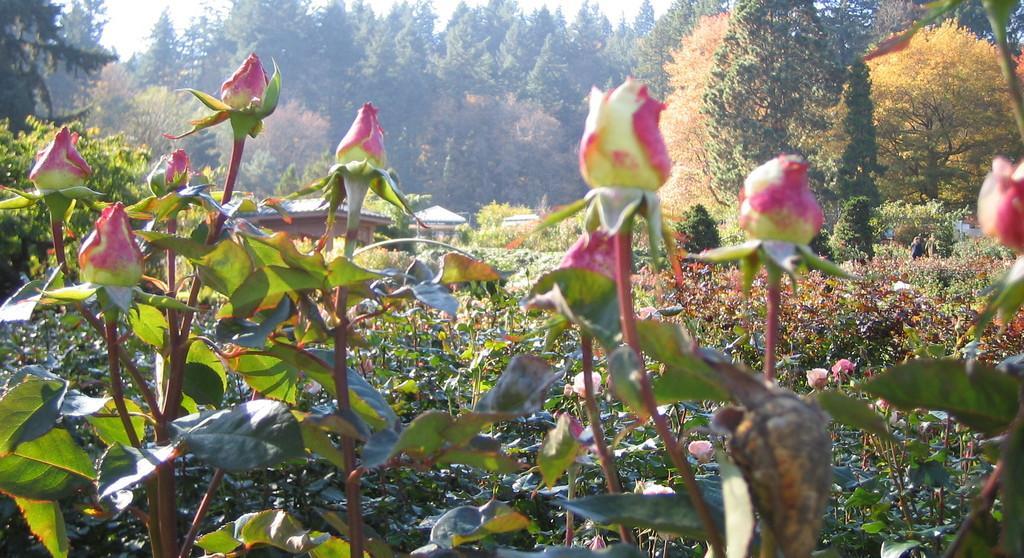How would you summarize this image in a sentence or two? In this image we can see that there are rose flower buds in the middle. In the background there are rose flower plants. At the top there are trees. In between the farm there are houses. 